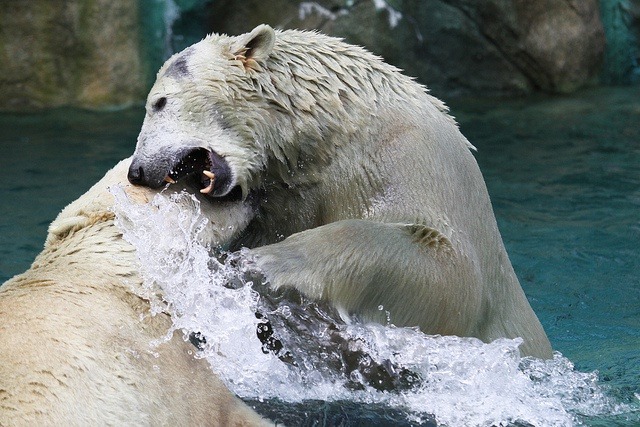Describe the objects in this image and their specific colors. I can see bear in black, darkgray, gray, and lightgray tones and bear in black, lightgray, darkgray, and tan tones in this image. 